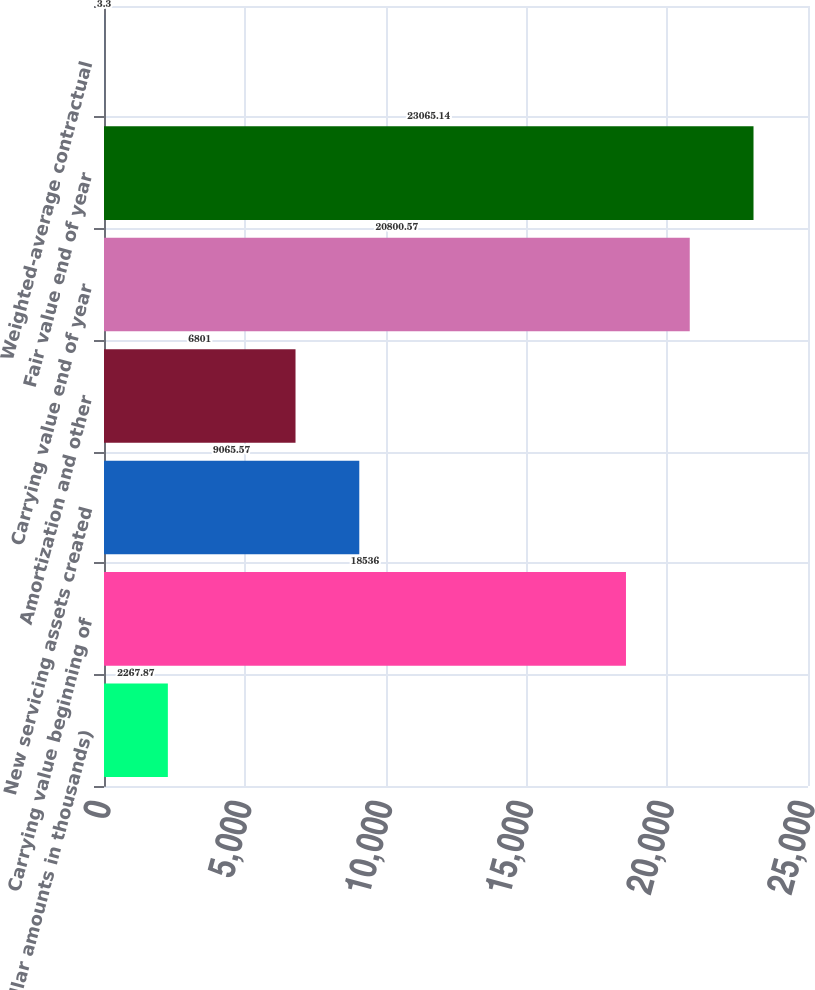<chart> <loc_0><loc_0><loc_500><loc_500><bar_chart><fcel>(dollar amounts in thousands)<fcel>Carrying value beginning of<fcel>New servicing assets created<fcel>Amortization and other<fcel>Carrying value end of year<fcel>Fair value end of year<fcel>Weighted-average contractual<nl><fcel>2267.87<fcel>18536<fcel>9065.57<fcel>6801<fcel>20800.6<fcel>23065.1<fcel>3.3<nl></chart> 